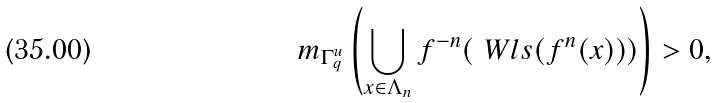<formula> <loc_0><loc_0><loc_500><loc_500>m _ { \Gamma _ { q } ^ { u } } \left ( \bigcup _ { x \in \Lambda _ { n } } f ^ { - n } ( \ W l s ( f ^ { n } ( x ) ) ) \right ) > 0 ,</formula> 